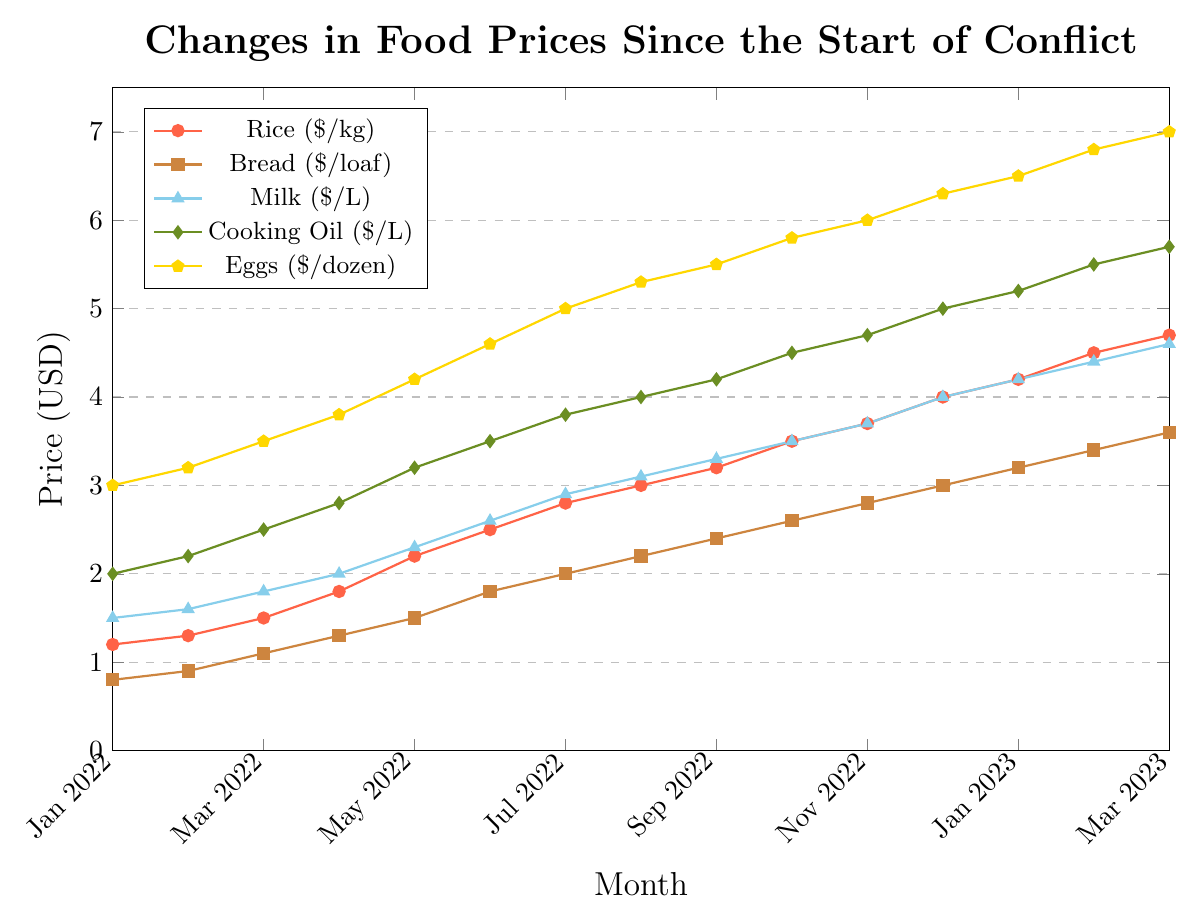What's the difference in the price of eggs from Jan 2022 to Mar 2023? From the visual representation, we can see that the price of eggs in Jan 2022 is $3.0 per dozen, and in Mar 2023, it's $7.0 per dozen. The difference can be calculated as $7.0 - $3.0 = $4.0
Answer: $4.0 Which item experienced the highest price increase over the period? By observing the slopes and end values in the chart, we notice eggs increased from $3.0 to $7.0, rice from $1.2 to $4.7, bread from $0.8 to $3.6, milk from $1.5 to $4.6, and cooking oil from $2.0 to $5.7. The highest increase is for eggs with a change of $4.0.
Answer: Eggs What is the price of cooking oil in Jan 2023, represented by the green diamond marker? Look for the green diamond marker corresponding to the entry for "Jan 2023", and observe its vertical position on the y-axis. The price of cooking oil in Jan 2023 is $5.2 per liter.
Answer: $5.2 Between which two consecutive months did rice experience the steepest price increase? To determine this, observe the red line representing rice prices. The largest vertical leap occurs between Jan 2022 to Feb 2022 ($1.2 to $1.3), Feb 2022 to Mar 2022 ($1.3 to $1.5) and so on. The steepest increase is between April 2022 ($1.8) and May 2022 ($2.2), a difference of $0.4.
Answer: Apr 2022 and May 2022 By how much did the price of milk change on average each month from Jan 2022 to Mar 2023? Calculate the total change for milk from Jan 2022 ($1.5) to Mar 2023 ($4.6), which is $4.6 - $1.5 = $3.1. There are 14 months between these intervals. The average monthly change is $3.1 / 14 ≈ $0.2214.
Answer: $0.2214 What is the overall trend observed for the price of bread? Visually inspecting the brown line representing bread prices shows a consistently rising trend from Jan 2022 to Mar 2023, increasing from $0.8 to $3.6.
Answer: Increasing How much did the price of rice increase between Jun 2022 and Dec 2022? The red line representing rice shows values of $2.5 in Jun 2022 and $4.0 in Dec 2022. The difference is $4.0 - $2.5 = $1.5.
Answer: $1.5 If the trend continues, what could be the potential price of eggs in April 2023? Observe the steady increasing trend in egg prices, which rose approximately $0.2 to $0.3 each month. If this trend continues, the price in March is $7.0; thus, in April 2023, a potential price could be $7.0 + $0.2 ≈ $7.2.
Answer: $7.2 How does the price of bread in Jul 2022 compare to the price in Jan 2023? Look at the brown squares representing bread for Jul 2022 and Jan 2023. Prices are $2.0 and $3.2, respectively. The price of bread in Jan 2023 is higher than in Jul 2022 by $3.2 - $2.0 = $1.2.
Answer: Higher by $1.2 